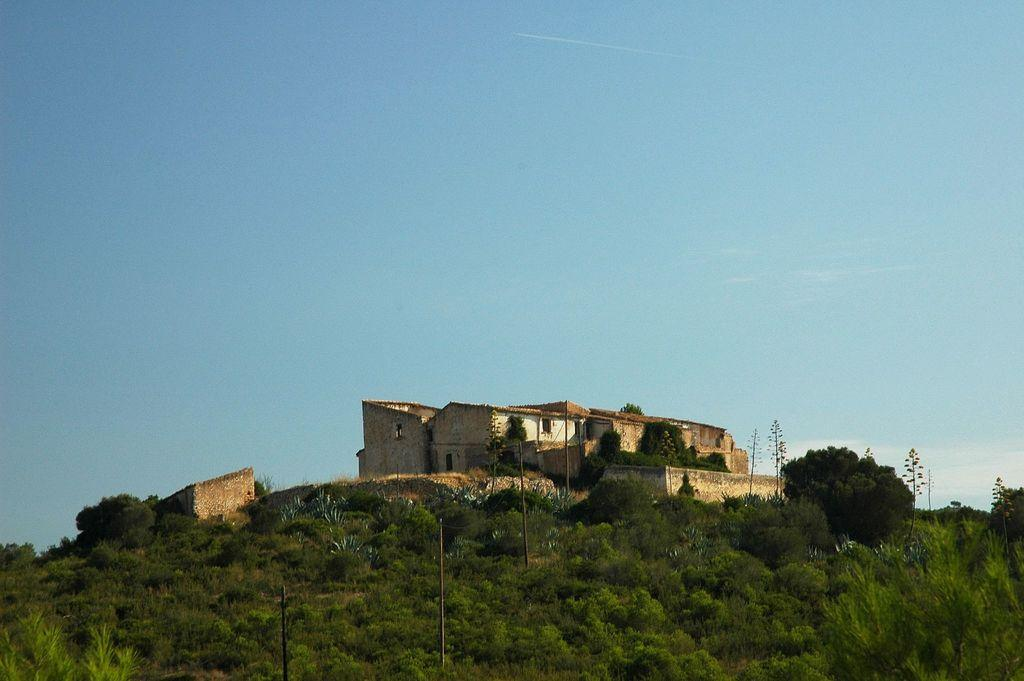What type of structures can be seen in the image? There are buildings in the image. What other elements are present in the image besides buildings? There are plants, poles, and trees in the image. What can be seen in the background of the image? The sky is visible in the background of the image. What type of bread is being eaten by the mouth in the image? There is no bread or mouth present in the image. 